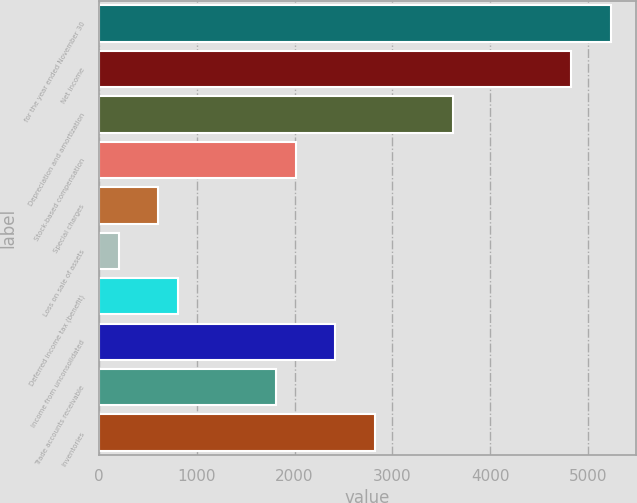Convert chart. <chart><loc_0><loc_0><loc_500><loc_500><bar_chart><fcel>for the year ended November 30<fcel>Net income<fcel>Depreciation and amortization<fcel>Stock-based compensation<fcel>Special charges<fcel>Loss on sale of assets<fcel>Deferred income tax (benefit)<fcel>Income from unconsolidated<fcel>Trade accounts receivable<fcel>Inventories<nl><fcel>5234.64<fcel>4832.06<fcel>3624.32<fcel>2014<fcel>604.97<fcel>202.39<fcel>806.26<fcel>2416.58<fcel>1812.71<fcel>2819.16<nl></chart> 